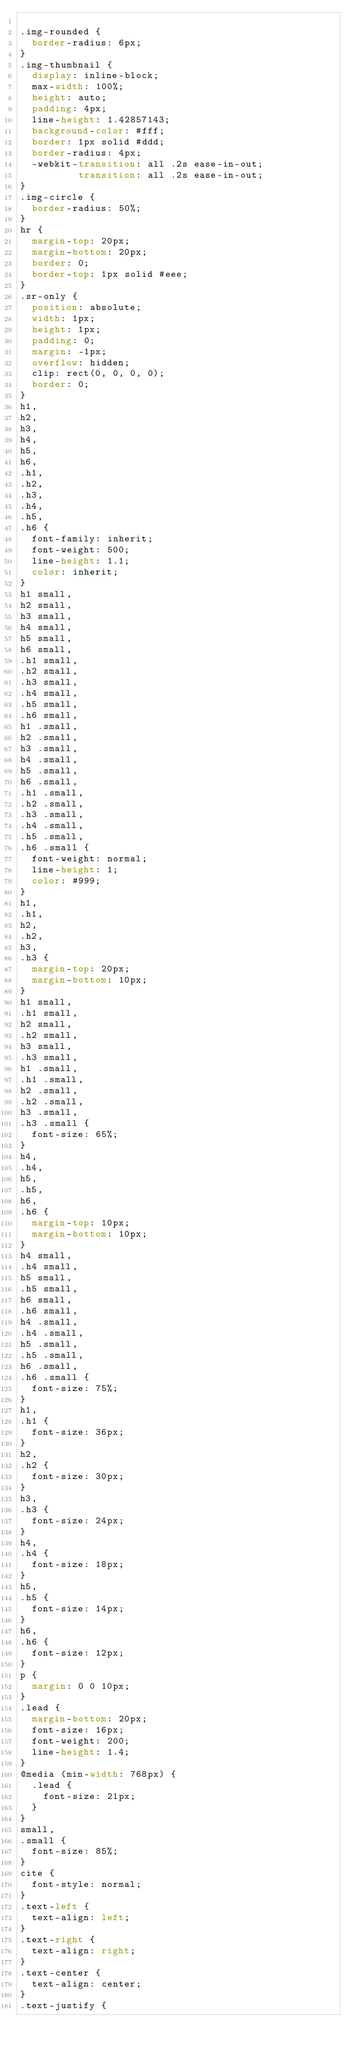<code> <loc_0><loc_0><loc_500><loc_500><_CSS_>
.img-rounded {
  border-radius: 6px;
}
.img-thumbnail {
  display: inline-block;
  max-width: 100%;
  height: auto;
  padding: 4px;
  line-height: 1.42857143;
  background-color: #fff;
  border: 1px solid #ddd;
  border-radius: 4px;
  -webkit-transition: all .2s ease-in-out;
          transition: all .2s ease-in-out;
}
.img-circle {
  border-radius: 50%;
}
hr {
  margin-top: 20px;
  margin-bottom: 20px;
  border: 0;
  border-top: 1px solid #eee;
}
.sr-only {
  position: absolute;
  width: 1px;
  height: 1px;
  padding: 0;
  margin: -1px;
  overflow: hidden;
  clip: rect(0, 0, 0, 0);
  border: 0;
}
h1,
h2,
h3,
h4,
h5,
h6,
.h1,
.h2,
.h3,
.h4,
.h5,
.h6 {
  font-family: inherit;
  font-weight: 500;
  line-height: 1.1;
  color: inherit;
}
h1 small,
h2 small,
h3 small,
h4 small,
h5 small,
h6 small,
.h1 small,
.h2 small,
.h3 small,
.h4 small,
.h5 small,
.h6 small,
h1 .small,
h2 .small,
h3 .small,
h4 .small,
h5 .small,
h6 .small,
.h1 .small,
.h2 .small,
.h3 .small,
.h4 .small,
.h5 .small,
.h6 .small {
  font-weight: normal;
  line-height: 1;
  color: #999;
}
h1,
.h1,
h2,
.h2,
h3,
.h3 {
  margin-top: 20px;
  margin-bottom: 10px;
}
h1 small,
.h1 small,
h2 small,
.h2 small,
h3 small,
.h3 small,
h1 .small,
.h1 .small,
h2 .small,
.h2 .small,
h3 .small,
.h3 .small {
  font-size: 65%;
}
h4,
.h4,
h5,
.h5,
h6,
.h6 {
  margin-top: 10px;
  margin-bottom: 10px;
}
h4 small,
.h4 small,
h5 small,
.h5 small,
h6 small,
.h6 small,
h4 .small,
.h4 .small,
h5 .small,
.h5 .small,
h6 .small,
.h6 .small {
  font-size: 75%;
}
h1,
.h1 {
  font-size: 36px;
}
h2,
.h2 {
  font-size: 30px;
}
h3,
.h3 {
  font-size: 24px;
}
h4,
.h4 {
  font-size: 18px;
}
h5,
.h5 {
  font-size: 14px;
}
h6,
.h6 {
  font-size: 12px;
}
p {
  margin: 0 0 10px;
}
.lead {
  margin-bottom: 20px;
  font-size: 16px;
  font-weight: 200;
  line-height: 1.4;
}
@media (min-width: 768px) {
  .lead {
    font-size: 21px;
  }
}
small,
.small {
  font-size: 85%;
}
cite {
  font-style: normal;
}
.text-left {
  text-align: left;
}
.text-right {
  text-align: right;
}
.text-center {
  text-align: center;
}
.text-justify {</code> 